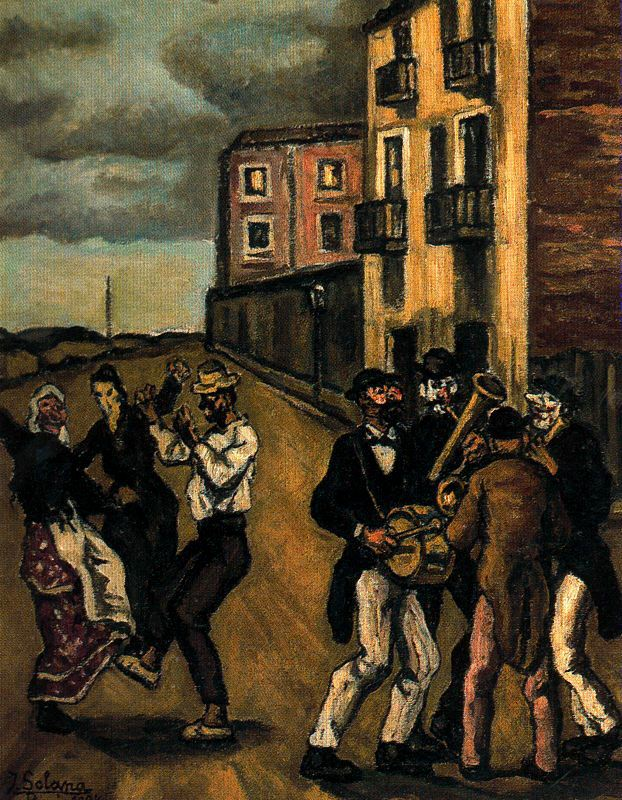If you were to add an element of fantasy to this painting, what would it be? Adding an element of fantasy to this painting, I would introduce magical creatures joining the celebration. Imagine mischievous fairies flitting around the dancers, their tiny, glowing forms leaving trails of sparkling light. In the background, ethereal figures could be seen emerging from the shadows, playing enchanted instruments that enhance the rhythm and melody of the music. The night sky could be filled with glowing constellations that come to life, dancing in harmony with the people below. This blend of the real and the fantastical would evoke a sense of wonder and enchantment, transforming the scene into a magical celebration where the boundaries between reality and fantasy blur. Describe a realistic scenario where this image might appear in history or literature. This image might appear in a historical novel set in a quaint European village during the late 19th century. The book could detail the lives of the villagers, their customs, and the challenges they face, culminating in a celebratory festival that brings everyone together. Such a scene could also be found in a literary work exploring themes of community and tradition, where the characters take a moment to revel in their shared culture and joy. Alternatively, it could be a historical account or a historical fiction piece that delves into the everyday lives of people during this era, utilizing this scene to highlight the importance of social gatherings and cultural preservation in times of change. Can you depict a shorter, but imaginative and realistic scenario involving the image? In a realistic scenario, this image could represent a moment from a local festival in a small European town. The festival occurs once a year, bringing together families and friends who dance in the streets to live band music. The painting captures a moment of pure joy and unity as the townspeople momentarily set aside their daily struggles to celebrate their heritage and community. It acts as a reminder of simpler times where people found happiness in the company of their loved ones and the music that binds them together. 